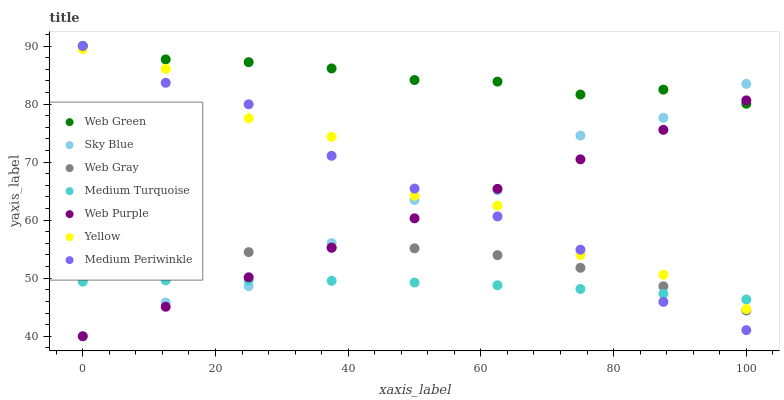Does Medium Turquoise have the minimum area under the curve?
Answer yes or no. Yes. Does Web Green have the maximum area under the curve?
Answer yes or no. Yes. Does Medium Periwinkle have the minimum area under the curve?
Answer yes or no. No. Does Medium Periwinkle have the maximum area under the curve?
Answer yes or no. No. Is Web Purple the smoothest?
Answer yes or no. Yes. Is Yellow the roughest?
Answer yes or no. Yes. Is Medium Periwinkle the smoothest?
Answer yes or no. No. Is Medium Periwinkle the roughest?
Answer yes or no. No. Does Web Purple have the lowest value?
Answer yes or no. Yes. Does Medium Periwinkle have the lowest value?
Answer yes or no. No. Does Web Green have the highest value?
Answer yes or no. Yes. Does Yellow have the highest value?
Answer yes or no. No. Is Web Gray less than Web Green?
Answer yes or no. Yes. Is Web Green greater than Yellow?
Answer yes or no. Yes. Does Medium Periwinkle intersect Web Green?
Answer yes or no. Yes. Is Medium Periwinkle less than Web Green?
Answer yes or no. No. Is Medium Periwinkle greater than Web Green?
Answer yes or no. No. Does Web Gray intersect Web Green?
Answer yes or no. No. 